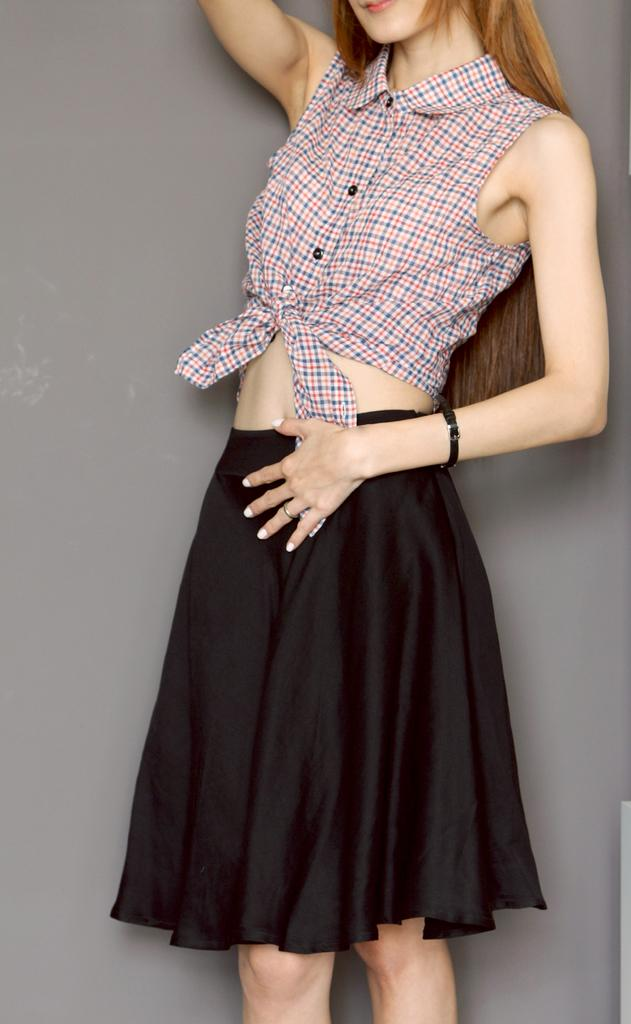Who is the main subject in the image? There is a woman in the center of the image. What is the woman wearing on her upper body? The woman is wearing a shirt. What color is the skirt the woman is wearing? The woman is wearing a black color skirt. What is the woman's posture in the image? The woman is standing. What can be seen in the background of the image? There is an object in the background that seems to be a wall. What type of gun can be seen in the woman's hand in the image? There is no gun present in the image; the woman is not holding anything in her hand. 